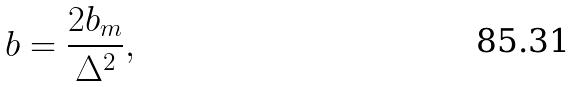<formula> <loc_0><loc_0><loc_500><loc_500>b = \frac { 2 b _ { m } } { \Delta ^ { 2 } } ,</formula> 